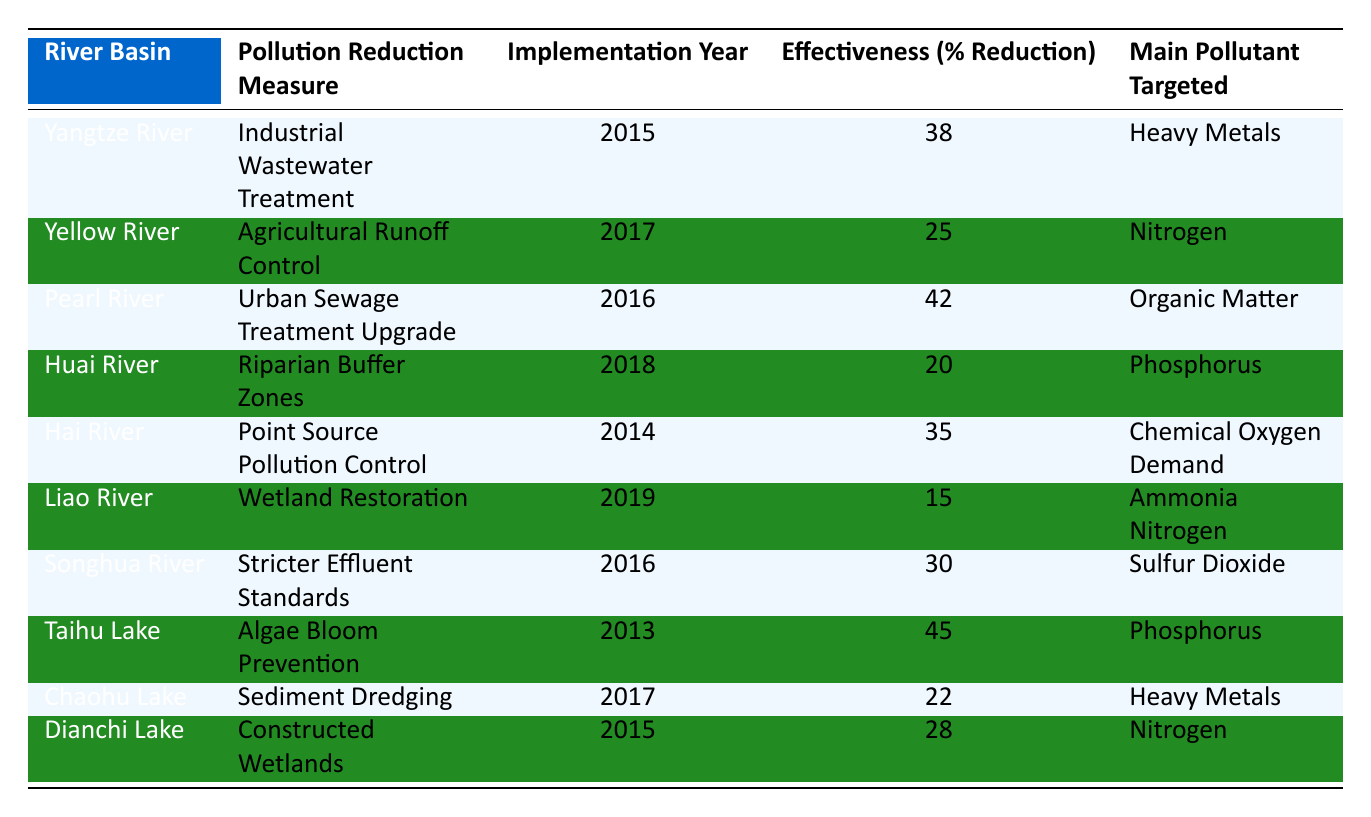What is the effectiveness percentage of the Pearl River pollution reduction measure? The table lists the effectiveness percentage for the Pearl River as 42%. This value corresponds directly to the row for the Pearl River in the column for Effectiveness (% Reduction).
Answer: 42% Which river basin implemented pollution reduction measures most recently? The table shows that the Liao River implemented its pollution reduction measure in 2019, making it the most recent.
Answer: Liao River What is the main pollutant targeted by the Taihu Lake's pollution reduction measure? The table indicates that the main pollutant targeted by the Taihu Lake's pollution reduction measure is Phosphorus. This can be found in the row corresponding to Taihu Lake.
Answer: Phosphorus Is the effectiveness of the riparian buffer zones in the Huai River above 20%? According to the table, the effectiveness for the Huai River is 20%, which means it is not above 20%.
Answer: No What was the average effectiveness percentage of all the pollution reduction measures listed in the table? To find the average, we first sum the effectiveness percentages: 38 + 25 + 42 + 20 + 35 + 15 + 30 + 45 + 22 + 28 =  360. There are 10 measures, so the average effectiveness is 360/10 = 36%.
Answer: 36% Was the percentage reduction of the pollution measure in the Hai River higher than that in the Yellow River? In the table, the effectiveness for the Hai River is 35% and for the Yellow River is 25%. Since 35% is greater than 25%, the answer is yes.
Answer: Yes What is the common pollutant targeted by the majority of the pollution reduction measures? By reviewing the pollutants targeted, Heavy Metals and Nitrogen appear twice, while others appear once each. So, Heavy Metals and Nitrogen are the common pollutants targeted.
Answer: Heavy Metals, Nitrogen Which river has the highest effectiveness percentage for pollution reduction measures? The table shows that Taihu Lake has the highest effectiveness percentage at 45%. This is the highest value across all rows in the effectiveness column.
Answer: Taihu Lake 